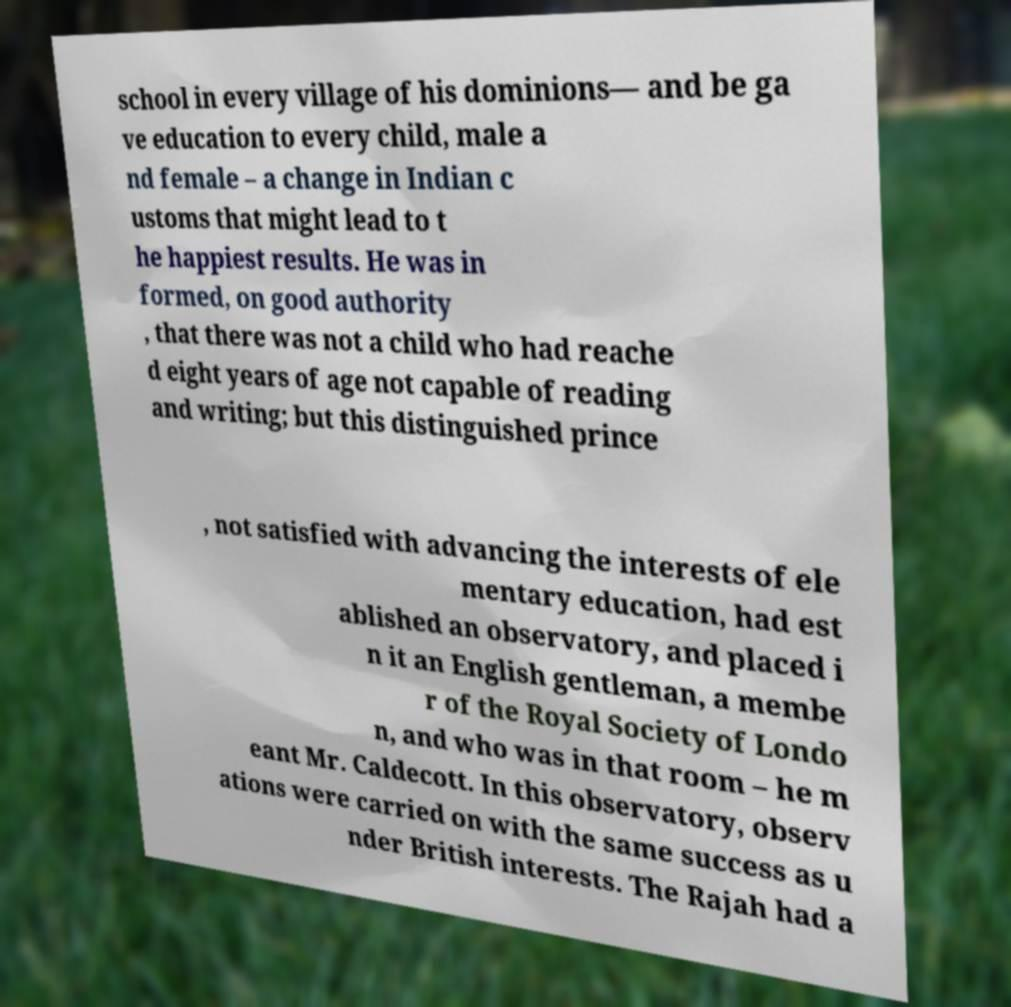There's text embedded in this image that I need extracted. Can you transcribe it verbatim? school in every village of his dominions— and be ga ve education to every child, male a nd female – a change in Indian c ustoms that might lead to t he happiest results. He was in formed, on good authority , that there was not a child who had reache d eight years of age not capable of reading and writing; but this distinguished prince , not satisfied with advancing the interests of ele mentary education, had est ablished an observatory, and placed i n it an English gentleman, a membe r of the Royal Society of Londo n, and who was in that room – he m eant Mr. Caldecott. In this observatory, observ ations were carried on with the same success as u nder British interests. The Rajah had a 